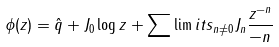<formula> <loc_0><loc_0><loc_500><loc_500>\phi ( z ) = \hat { q } + J _ { 0 } \log z + \sum \lim i t s _ { n \neq 0 } J _ { n } \frac { z ^ { - n } } { - n }</formula> 